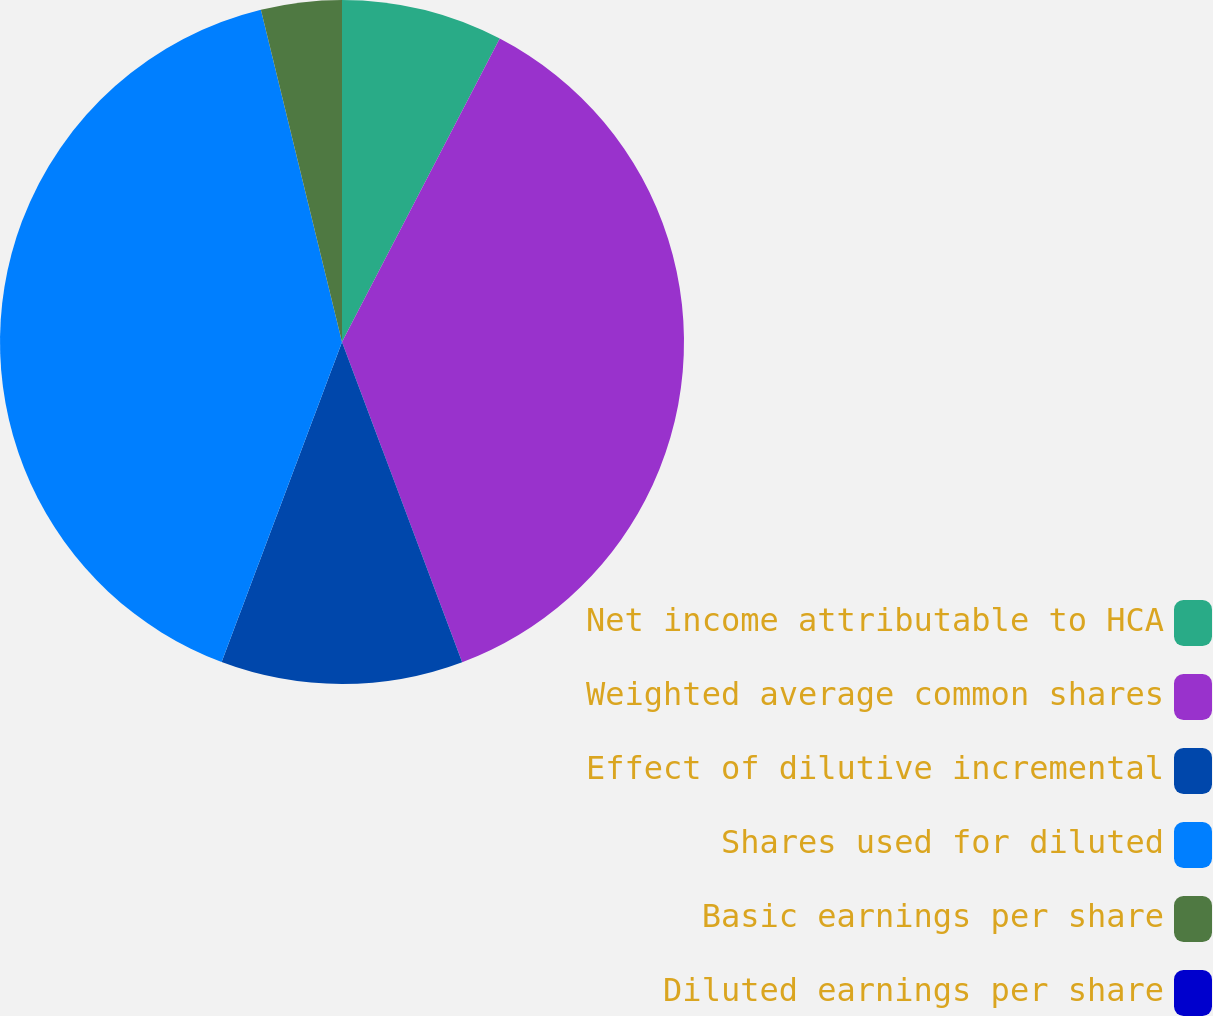<chart> <loc_0><loc_0><loc_500><loc_500><pie_chart><fcel>Net income attributable to HCA<fcel>Weighted average common shares<fcel>Effect of dilutive incremental<fcel>Shares used for diluted<fcel>Basic earnings per share<fcel>Diluted earnings per share<nl><fcel>7.63%<fcel>36.65%<fcel>11.44%<fcel>40.46%<fcel>3.81%<fcel>0.0%<nl></chart> 